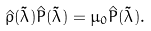<formula> <loc_0><loc_0><loc_500><loc_500>\hat { \rho } ( \tilde { \lambda } ) \hat { P } ( \tilde { \lambda } ) = \mu _ { 0 } \hat { P } ( \tilde { \lambda } ) .</formula> 